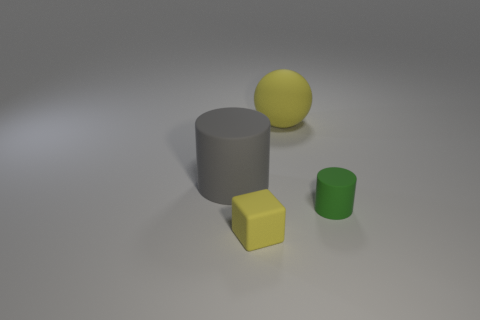Are there more big gray things that are right of the large matte cylinder than yellow rubber blocks on the left side of the rubber sphere? no 